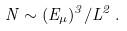Convert formula to latex. <formula><loc_0><loc_0><loc_500><loc_500>N \sim ( E _ { \mu } ) ^ { 3 } / L ^ { 2 } \, .</formula> 